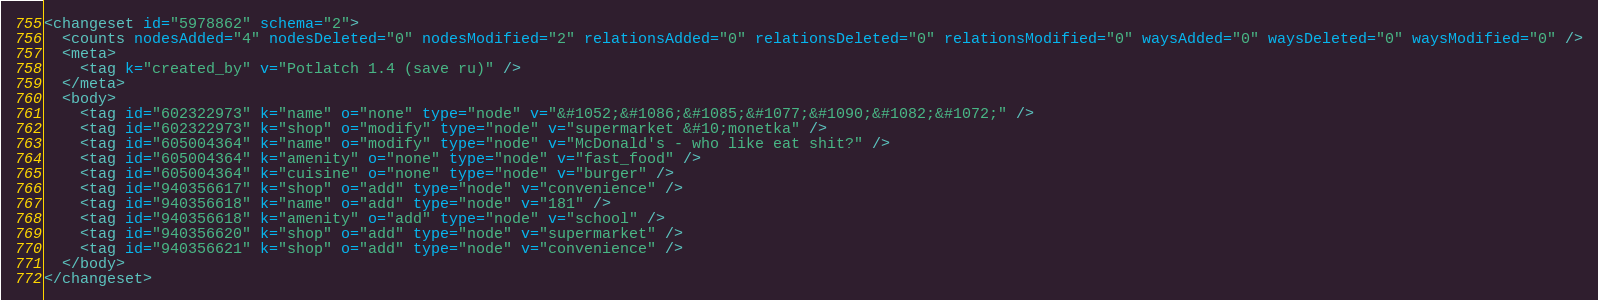Convert code to text. <code><loc_0><loc_0><loc_500><loc_500><_XML_><changeset id="5978862" schema="2">
  <counts nodesAdded="4" nodesDeleted="0" nodesModified="2" relationsAdded="0" relationsDeleted="0" relationsModified="0" waysAdded="0" waysDeleted="0" waysModified="0" />
  <meta>
    <tag k="created_by" v="Potlatch 1.4 (save ru)" />
  </meta>
  <body>
    <tag id="602322973" k="name" o="none" type="node" v="&#1052;&#1086;&#1085;&#1077;&#1090;&#1082;&#1072;" />
    <tag id="602322973" k="shop" o="modify" type="node" v="supermarket &#10;monetka" />
    <tag id="605004364" k="name" o="modify" type="node" v="McDonald's - who like eat shit?" />
    <tag id="605004364" k="amenity" o="none" type="node" v="fast_food" />
    <tag id="605004364" k="cuisine" o="none" type="node" v="burger" />
    <tag id="940356617" k="shop" o="add" type="node" v="convenience" />
    <tag id="940356618" k="name" o="add" type="node" v="181" />
    <tag id="940356618" k="amenity" o="add" type="node" v="school" />
    <tag id="940356620" k="shop" o="add" type="node" v="supermarket" />
    <tag id="940356621" k="shop" o="add" type="node" v="convenience" />
  </body>
</changeset>
</code> 